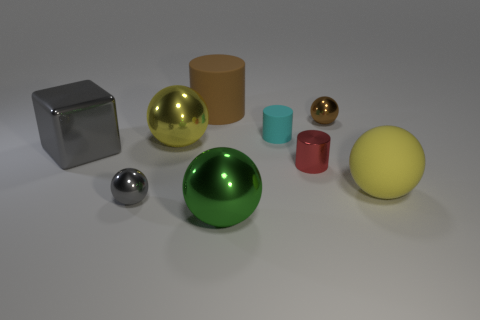Subtract all brown cylinders. How many cylinders are left? 2 Subtract all brown cylinders. How many cylinders are left? 2 Subtract all blocks. How many objects are left? 8 Subtract 3 cylinders. How many cylinders are left? 0 Subtract all purple cylinders. How many green blocks are left? 0 Subtract all big gray objects. Subtract all yellow metal spheres. How many objects are left? 7 Add 8 tiny rubber objects. How many tiny rubber objects are left? 9 Add 3 large red metal things. How many large red metal things exist? 3 Subtract 0 blue cylinders. How many objects are left? 9 Subtract all purple spheres. Subtract all cyan cubes. How many spheres are left? 5 